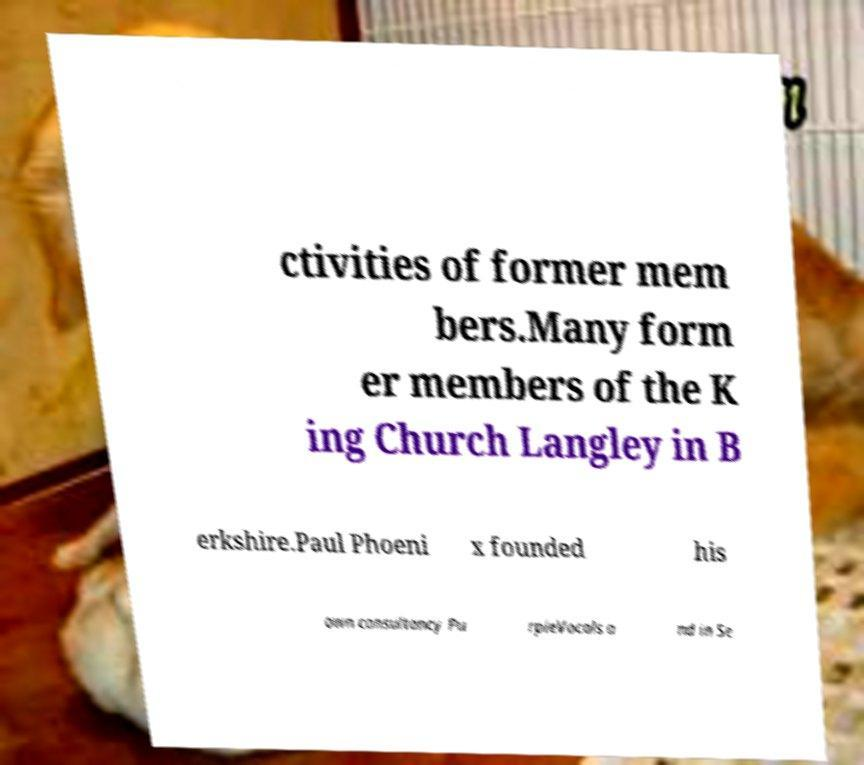Please identify and transcribe the text found in this image. ctivities of former mem bers.Many form er members of the K ing Church Langley in B erkshire.Paul Phoeni x founded his own consultancy Pu rpleVocals a nd in Se 